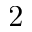<formula> <loc_0><loc_0><loc_500><loc_500>2</formula> 